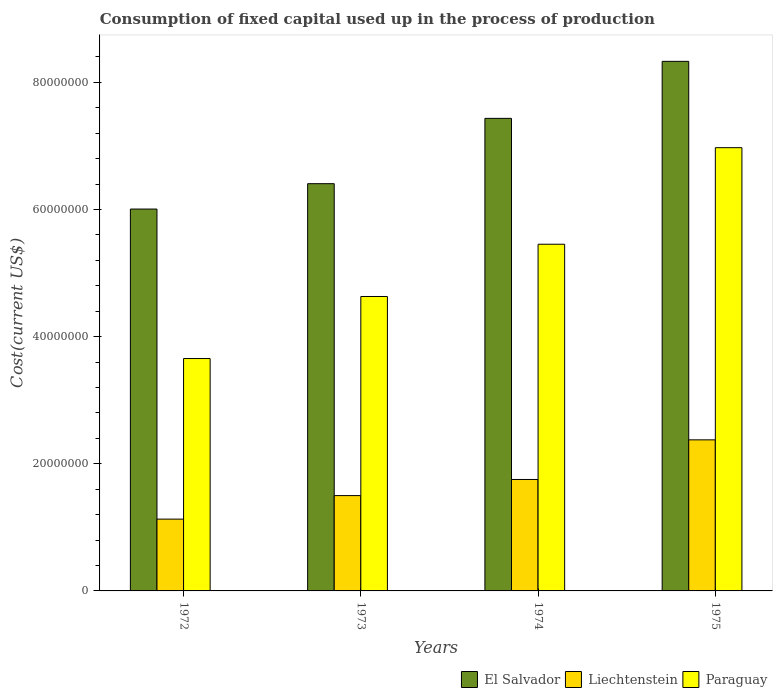How many different coloured bars are there?
Your answer should be compact. 3. How many groups of bars are there?
Keep it short and to the point. 4. Are the number of bars per tick equal to the number of legend labels?
Your answer should be compact. Yes. How many bars are there on the 3rd tick from the right?
Make the answer very short. 3. What is the label of the 1st group of bars from the left?
Give a very brief answer. 1972. In how many cases, is the number of bars for a given year not equal to the number of legend labels?
Give a very brief answer. 0. What is the amount consumed in the process of production in Liechtenstein in 1975?
Make the answer very short. 2.38e+07. Across all years, what is the maximum amount consumed in the process of production in Liechtenstein?
Provide a short and direct response. 2.38e+07. Across all years, what is the minimum amount consumed in the process of production in El Salvador?
Ensure brevity in your answer.  6.01e+07. In which year was the amount consumed in the process of production in Paraguay maximum?
Provide a short and direct response. 1975. What is the total amount consumed in the process of production in Liechtenstein in the graph?
Your answer should be very brief. 6.76e+07. What is the difference between the amount consumed in the process of production in Liechtenstein in 1974 and that in 1975?
Keep it short and to the point. -6.23e+06. What is the difference between the amount consumed in the process of production in El Salvador in 1973 and the amount consumed in the process of production in Liechtenstein in 1975?
Keep it short and to the point. 4.03e+07. What is the average amount consumed in the process of production in Liechtenstein per year?
Provide a short and direct response. 1.69e+07. In the year 1973, what is the difference between the amount consumed in the process of production in Paraguay and amount consumed in the process of production in El Salvador?
Ensure brevity in your answer.  -1.77e+07. In how many years, is the amount consumed in the process of production in El Salvador greater than 44000000 US$?
Offer a very short reply. 4. What is the ratio of the amount consumed in the process of production in El Salvador in 1972 to that in 1973?
Give a very brief answer. 0.94. What is the difference between the highest and the second highest amount consumed in the process of production in Liechtenstein?
Give a very brief answer. 6.23e+06. What is the difference between the highest and the lowest amount consumed in the process of production in El Salvador?
Provide a succinct answer. 2.32e+07. In how many years, is the amount consumed in the process of production in El Salvador greater than the average amount consumed in the process of production in El Salvador taken over all years?
Give a very brief answer. 2. What does the 2nd bar from the left in 1974 represents?
Offer a terse response. Liechtenstein. What does the 2nd bar from the right in 1975 represents?
Offer a terse response. Liechtenstein. Are all the bars in the graph horizontal?
Your response must be concise. No. How many years are there in the graph?
Give a very brief answer. 4. Where does the legend appear in the graph?
Your answer should be compact. Bottom right. How are the legend labels stacked?
Your answer should be very brief. Horizontal. What is the title of the graph?
Keep it short and to the point. Consumption of fixed capital used up in the process of production. What is the label or title of the X-axis?
Your answer should be compact. Years. What is the label or title of the Y-axis?
Offer a very short reply. Cost(current US$). What is the Cost(current US$) in El Salvador in 1972?
Offer a terse response. 6.01e+07. What is the Cost(current US$) in Liechtenstein in 1972?
Ensure brevity in your answer.  1.13e+07. What is the Cost(current US$) of Paraguay in 1972?
Ensure brevity in your answer.  3.66e+07. What is the Cost(current US$) of El Salvador in 1973?
Offer a very short reply. 6.41e+07. What is the Cost(current US$) in Liechtenstein in 1973?
Provide a short and direct response. 1.50e+07. What is the Cost(current US$) of Paraguay in 1973?
Give a very brief answer. 4.63e+07. What is the Cost(current US$) in El Salvador in 1974?
Offer a very short reply. 7.43e+07. What is the Cost(current US$) in Liechtenstein in 1974?
Your response must be concise. 1.75e+07. What is the Cost(current US$) in Paraguay in 1974?
Your answer should be very brief. 5.45e+07. What is the Cost(current US$) of El Salvador in 1975?
Provide a short and direct response. 8.33e+07. What is the Cost(current US$) of Liechtenstein in 1975?
Keep it short and to the point. 2.38e+07. What is the Cost(current US$) in Paraguay in 1975?
Keep it short and to the point. 6.97e+07. Across all years, what is the maximum Cost(current US$) in El Salvador?
Your response must be concise. 8.33e+07. Across all years, what is the maximum Cost(current US$) in Liechtenstein?
Keep it short and to the point. 2.38e+07. Across all years, what is the maximum Cost(current US$) of Paraguay?
Your answer should be very brief. 6.97e+07. Across all years, what is the minimum Cost(current US$) in El Salvador?
Provide a succinct answer. 6.01e+07. Across all years, what is the minimum Cost(current US$) of Liechtenstein?
Your answer should be very brief. 1.13e+07. Across all years, what is the minimum Cost(current US$) of Paraguay?
Your answer should be very brief. 3.66e+07. What is the total Cost(current US$) in El Salvador in the graph?
Provide a succinct answer. 2.82e+08. What is the total Cost(current US$) of Liechtenstein in the graph?
Ensure brevity in your answer.  6.76e+07. What is the total Cost(current US$) in Paraguay in the graph?
Your answer should be very brief. 2.07e+08. What is the difference between the Cost(current US$) in El Salvador in 1972 and that in 1973?
Make the answer very short. -3.99e+06. What is the difference between the Cost(current US$) of Liechtenstein in 1972 and that in 1973?
Your response must be concise. -3.70e+06. What is the difference between the Cost(current US$) of Paraguay in 1972 and that in 1973?
Make the answer very short. -9.76e+06. What is the difference between the Cost(current US$) of El Salvador in 1972 and that in 1974?
Make the answer very short. -1.43e+07. What is the difference between the Cost(current US$) of Liechtenstein in 1972 and that in 1974?
Your answer should be very brief. -6.24e+06. What is the difference between the Cost(current US$) of Paraguay in 1972 and that in 1974?
Provide a short and direct response. -1.80e+07. What is the difference between the Cost(current US$) in El Salvador in 1972 and that in 1975?
Make the answer very short. -2.32e+07. What is the difference between the Cost(current US$) in Liechtenstein in 1972 and that in 1975?
Offer a terse response. -1.25e+07. What is the difference between the Cost(current US$) of Paraguay in 1972 and that in 1975?
Offer a very short reply. -3.32e+07. What is the difference between the Cost(current US$) in El Salvador in 1973 and that in 1974?
Ensure brevity in your answer.  -1.03e+07. What is the difference between the Cost(current US$) in Liechtenstein in 1973 and that in 1974?
Offer a terse response. -2.54e+06. What is the difference between the Cost(current US$) in Paraguay in 1973 and that in 1974?
Give a very brief answer. -8.22e+06. What is the difference between the Cost(current US$) in El Salvador in 1973 and that in 1975?
Your response must be concise. -1.92e+07. What is the difference between the Cost(current US$) in Liechtenstein in 1973 and that in 1975?
Your answer should be very brief. -8.77e+06. What is the difference between the Cost(current US$) in Paraguay in 1973 and that in 1975?
Your response must be concise. -2.34e+07. What is the difference between the Cost(current US$) of El Salvador in 1974 and that in 1975?
Make the answer very short. -8.97e+06. What is the difference between the Cost(current US$) of Liechtenstein in 1974 and that in 1975?
Your response must be concise. -6.23e+06. What is the difference between the Cost(current US$) in Paraguay in 1974 and that in 1975?
Your response must be concise. -1.52e+07. What is the difference between the Cost(current US$) of El Salvador in 1972 and the Cost(current US$) of Liechtenstein in 1973?
Provide a succinct answer. 4.51e+07. What is the difference between the Cost(current US$) of El Salvador in 1972 and the Cost(current US$) of Paraguay in 1973?
Offer a terse response. 1.38e+07. What is the difference between the Cost(current US$) in Liechtenstein in 1972 and the Cost(current US$) in Paraguay in 1973?
Your answer should be compact. -3.50e+07. What is the difference between the Cost(current US$) of El Salvador in 1972 and the Cost(current US$) of Liechtenstein in 1974?
Provide a short and direct response. 4.25e+07. What is the difference between the Cost(current US$) in El Salvador in 1972 and the Cost(current US$) in Paraguay in 1974?
Your response must be concise. 5.53e+06. What is the difference between the Cost(current US$) in Liechtenstein in 1972 and the Cost(current US$) in Paraguay in 1974?
Provide a succinct answer. -4.32e+07. What is the difference between the Cost(current US$) of El Salvador in 1972 and the Cost(current US$) of Liechtenstein in 1975?
Ensure brevity in your answer.  3.63e+07. What is the difference between the Cost(current US$) of El Salvador in 1972 and the Cost(current US$) of Paraguay in 1975?
Your answer should be compact. -9.66e+06. What is the difference between the Cost(current US$) in Liechtenstein in 1972 and the Cost(current US$) in Paraguay in 1975?
Offer a terse response. -5.84e+07. What is the difference between the Cost(current US$) of El Salvador in 1973 and the Cost(current US$) of Liechtenstein in 1974?
Your answer should be very brief. 4.65e+07. What is the difference between the Cost(current US$) of El Salvador in 1973 and the Cost(current US$) of Paraguay in 1974?
Make the answer very short. 9.52e+06. What is the difference between the Cost(current US$) in Liechtenstein in 1973 and the Cost(current US$) in Paraguay in 1974?
Your answer should be very brief. -3.95e+07. What is the difference between the Cost(current US$) of El Salvador in 1973 and the Cost(current US$) of Liechtenstein in 1975?
Give a very brief answer. 4.03e+07. What is the difference between the Cost(current US$) in El Salvador in 1973 and the Cost(current US$) in Paraguay in 1975?
Provide a succinct answer. -5.66e+06. What is the difference between the Cost(current US$) in Liechtenstein in 1973 and the Cost(current US$) in Paraguay in 1975?
Keep it short and to the point. -5.47e+07. What is the difference between the Cost(current US$) in El Salvador in 1974 and the Cost(current US$) in Liechtenstein in 1975?
Offer a very short reply. 5.06e+07. What is the difference between the Cost(current US$) in El Salvador in 1974 and the Cost(current US$) in Paraguay in 1975?
Provide a succinct answer. 4.61e+06. What is the difference between the Cost(current US$) in Liechtenstein in 1974 and the Cost(current US$) in Paraguay in 1975?
Provide a succinct answer. -5.22e+07. What is the average Cost(current US$) of El Salvador per year?
Keep it short and to the point. 7.04e+07. What is the average Cost(current US$) in Liechtenstein per year?
Give a very brief answer. 1.69e+07. What is the average Cost(current US$) of Paraguay per year?
Offer a very short reply. 5.18e+07. In the year 1972, what is the difference between the Cost(current US$) of El Salvador and Cost(current US$) of Liechtenstein?
Give a very brief answer. 4.88e+07. In the year 1972, what is the difference between the Cost(current US$) of El Salvador and Cost(current US$) of Paraguay?
Provide a succinct answer. 2.35e+07. In the year 1972, what is the difference between the Cost(current US$) of Liechtenstein and Cost(current US$) of Paraguay?
Give a very brief answer. -2.53e+07. In the year 1973, what is the difference between the Cost(current US$) of El Salvador and Cost(current US$) of Liechtenstein?
Make the answer very short. 4.91e+07. In the year 1973, what is the difference between the Cost(current US$) of El Salvador and Cost(current US$) of Paraguay?
Your answer should be very brief. 1.77e+07. In the year 1973, what is the difference between the Cost(current US$) in Liechtenstein and Cost(current US$) in Paraguay?
Your answer should be very brief. -3.13e+07. In the year 1974, what is the difference between the Cost(current US$) in El Salvador and Cost(current US$) in Liechtenstein?
Offer a terse response. 5.68e+07. In the year 1974, what is the difference between the Cost(current US$) of El Salvador and Cost(current US$) of Paraguay?
Offer a terse response. 1.98e+07. In the year 1974, what is the difference between the Cost(current US$) in Liechtenstein and Cost(current US$) in Paraguay?
Your answer should be compact. -3.70e+07. In the year 1975, what is the difference between the Cost(current US$) in El Salvador and Cost(current US$) in Liechtenstein?
Offer a terse response. 5.95e+07. In the year 1975, what is the difference between the Cost(current US$) in El Salvador and Cost(current US$) in Paraguay?
Your answer should be very brief. 1.36e+07. In the year 1975, what is the difference between the Cost(current US$) of Liechtenstein and Cost(current US$) of Paraguay?
Your answer should be compact. -4.60e+07. What is the ratio of the Cost(current US$) in El Salvador in 1972 to that in 1973?
Your answer should be compact. 0.94. What is the ratio of the Cost(current US$) in Liechtenstein in 1972 to that in 1973?
Your response must be concise. 0.75. What is the ratio of the Cost(current US$) in Paraguay in 1972 to that in 1973?
Your answer should be very brief. 0.79. What is the ratio of the Cost(current US$) in El Salvador in 1972 to that in 1974?
Your answer should be compact. 0.81. What is the ratio of the Cost(current US$) in Liechtenstein in 1972 to that in 1974?
Offer a terse response. 0.64. What is the ratio of the Cost(current US$) of Paraguay in 1972 to that in 1974?
Provide a short and direct response. 0.67. What is the ratio of the Cost(current US$) in El Salvador in 1972 to that in 1975?
Keep it short and to the point. 0.72. What is the ratio of the Cost(current US$) of Liechtenstein in 1972 to that in 1975?
Provide a short and direct response. 0.48. What is the ratio of the Cost(current US$) of Paraguay in 1972 to that in 1975?
Provide a short and direct response. 0.52. What is the ratio of the Cost(current US$) in El Salvador in 1973 to that in 1974?
Your answer should be compact. 0.86. What is the ratio of the Cost(current US$) of Liechtenstein in 1973 to that in 1974?
Offer a terse response. 0.86. What is the ratio of the Cost(current US$) of Paraguay in 1973 to that in 1974?
Offer a terse response. 0.85. What is the ratio of the Cost(current US$) in El Salvador in 1973 to that in 1975?
Offer a very short reply. 0.77. What is the ratio of the Cost(current US$) of Liechtenstein in 1973 to that in 1975?
Your response must be concise. 0.63. What is the ratio of the Cost(current US$) of Paraguay in 1973 to that in 1975?
Provide a succinct answer. 0.66. What is the ratio of the Cost(current US$) of El Salvador in 1974 to that in 1975?
Keep it short and to the point. 0.89. What is the ratio of the Cost(current US$) of Liechtenstein in 1974 to that in 1975?
Offer a very short reply. 0.74. What is the ratio of the Cost(current US$) in Paraguay in 1974 to that in 1975?
Give a very brief answer. 0.78. What is the difference between the highest and the second highest Cost(current US$) of El Salvador?
Your answer should be very brief. 8.97e+06. What is the difference between the highest and the second highest Cost(current US$) in Liechtenstein?
Your response must be concise. 6.23e+06. What is the difference between the highest and the second highest Cost(current US$) in Paraguay?
Your answer should be compact. 1.52e+07. What is the difference between the highest and the lowest Cost(current US$) of El Salvador?
Your answer should be very brief. 2.32e+07. What is the difference between the highest and the lowest Cost(current US$) in Liechtenstein?
Your answer should be very brief. 1.25e+07. What is the difference between the highest and the lowest Cost(current US$) in Paraguay?
Your answer should be compact. 3.32e+07. 